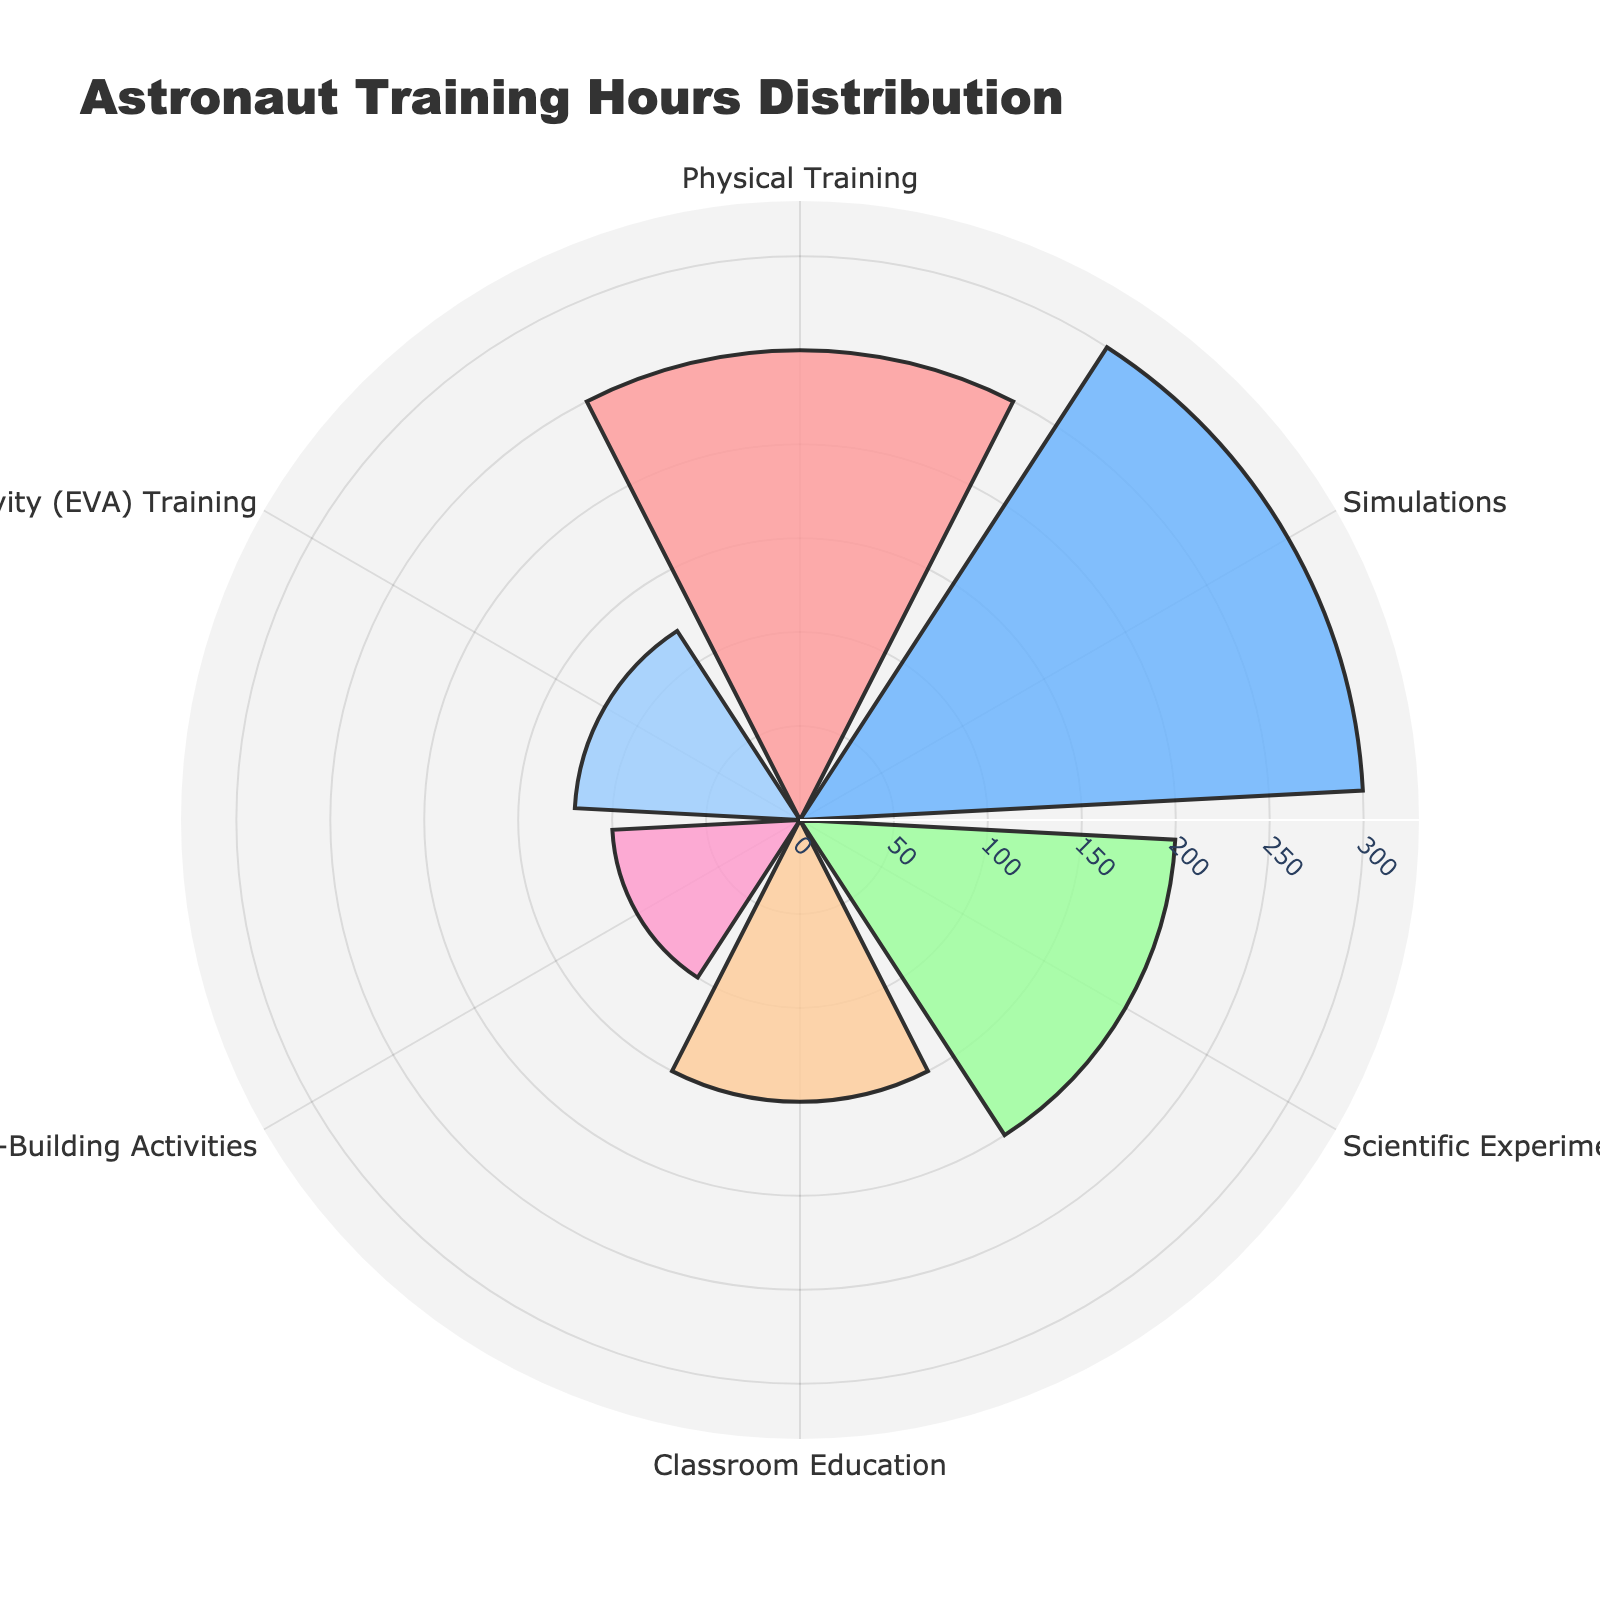What is the title of the chart? The title is located at the top of the chart and is usually in a distinct font size and style.
Answer: Astronaut Training Hours Distribution What is the training module with the highest number of hours? By observing which category has the largest radial distance (bar extending the furthest from the center), we can identify the module with the highest hours.
Answer: Simulations How many training modules are displayed on the chart? Count the distinct segments (bars) around the circle of the polar area chart.
Answer: 6 Which training module has fewer hours, Classroom Education or Team-Building Activities? Comparing the radial lengths of the segments for Classroom Education and Team-Building Activities, the shorter one has fewer hours.
Answer: Team-Building Activities What is the sum of training hours for Physical Training and Scientific Experiments? Find the training hours for both categories and add them: Physical Training (250 hrs) + Scientific Experiments (200 hrs).
Answer: 450 What is the difference in training hours between Simulations and Extravehicular Activity (EVA) Training? Calculate the difference between the two: Simulations (300 hrs) - EVA Training (120 hrs).
Answer: 180 Which category has the smallest representation in the chart? Identify the training module with the shortest radial length in the polar area chart.
Answer: Team-Building Activities Is the number of hours spent on Classroom Education more or less than half of the hours spent on Simulations? Compare Classroom Education hours to half of Simulation hours: Is 150 less than or greater than 150 (half of 300)?
Answer: Equal What is the range of the training hours depicted on the chart? The range is found by subtracting the smallest value from the largest value: 300 (Simulations) - 100 (Team-Building Activities).
Answer: 200 How many hours are allocated to EVA Training? Look for the segment labeled "Extravehicular Activity (EVA) Training" and read its corresponding radial length.
Answer: 120 